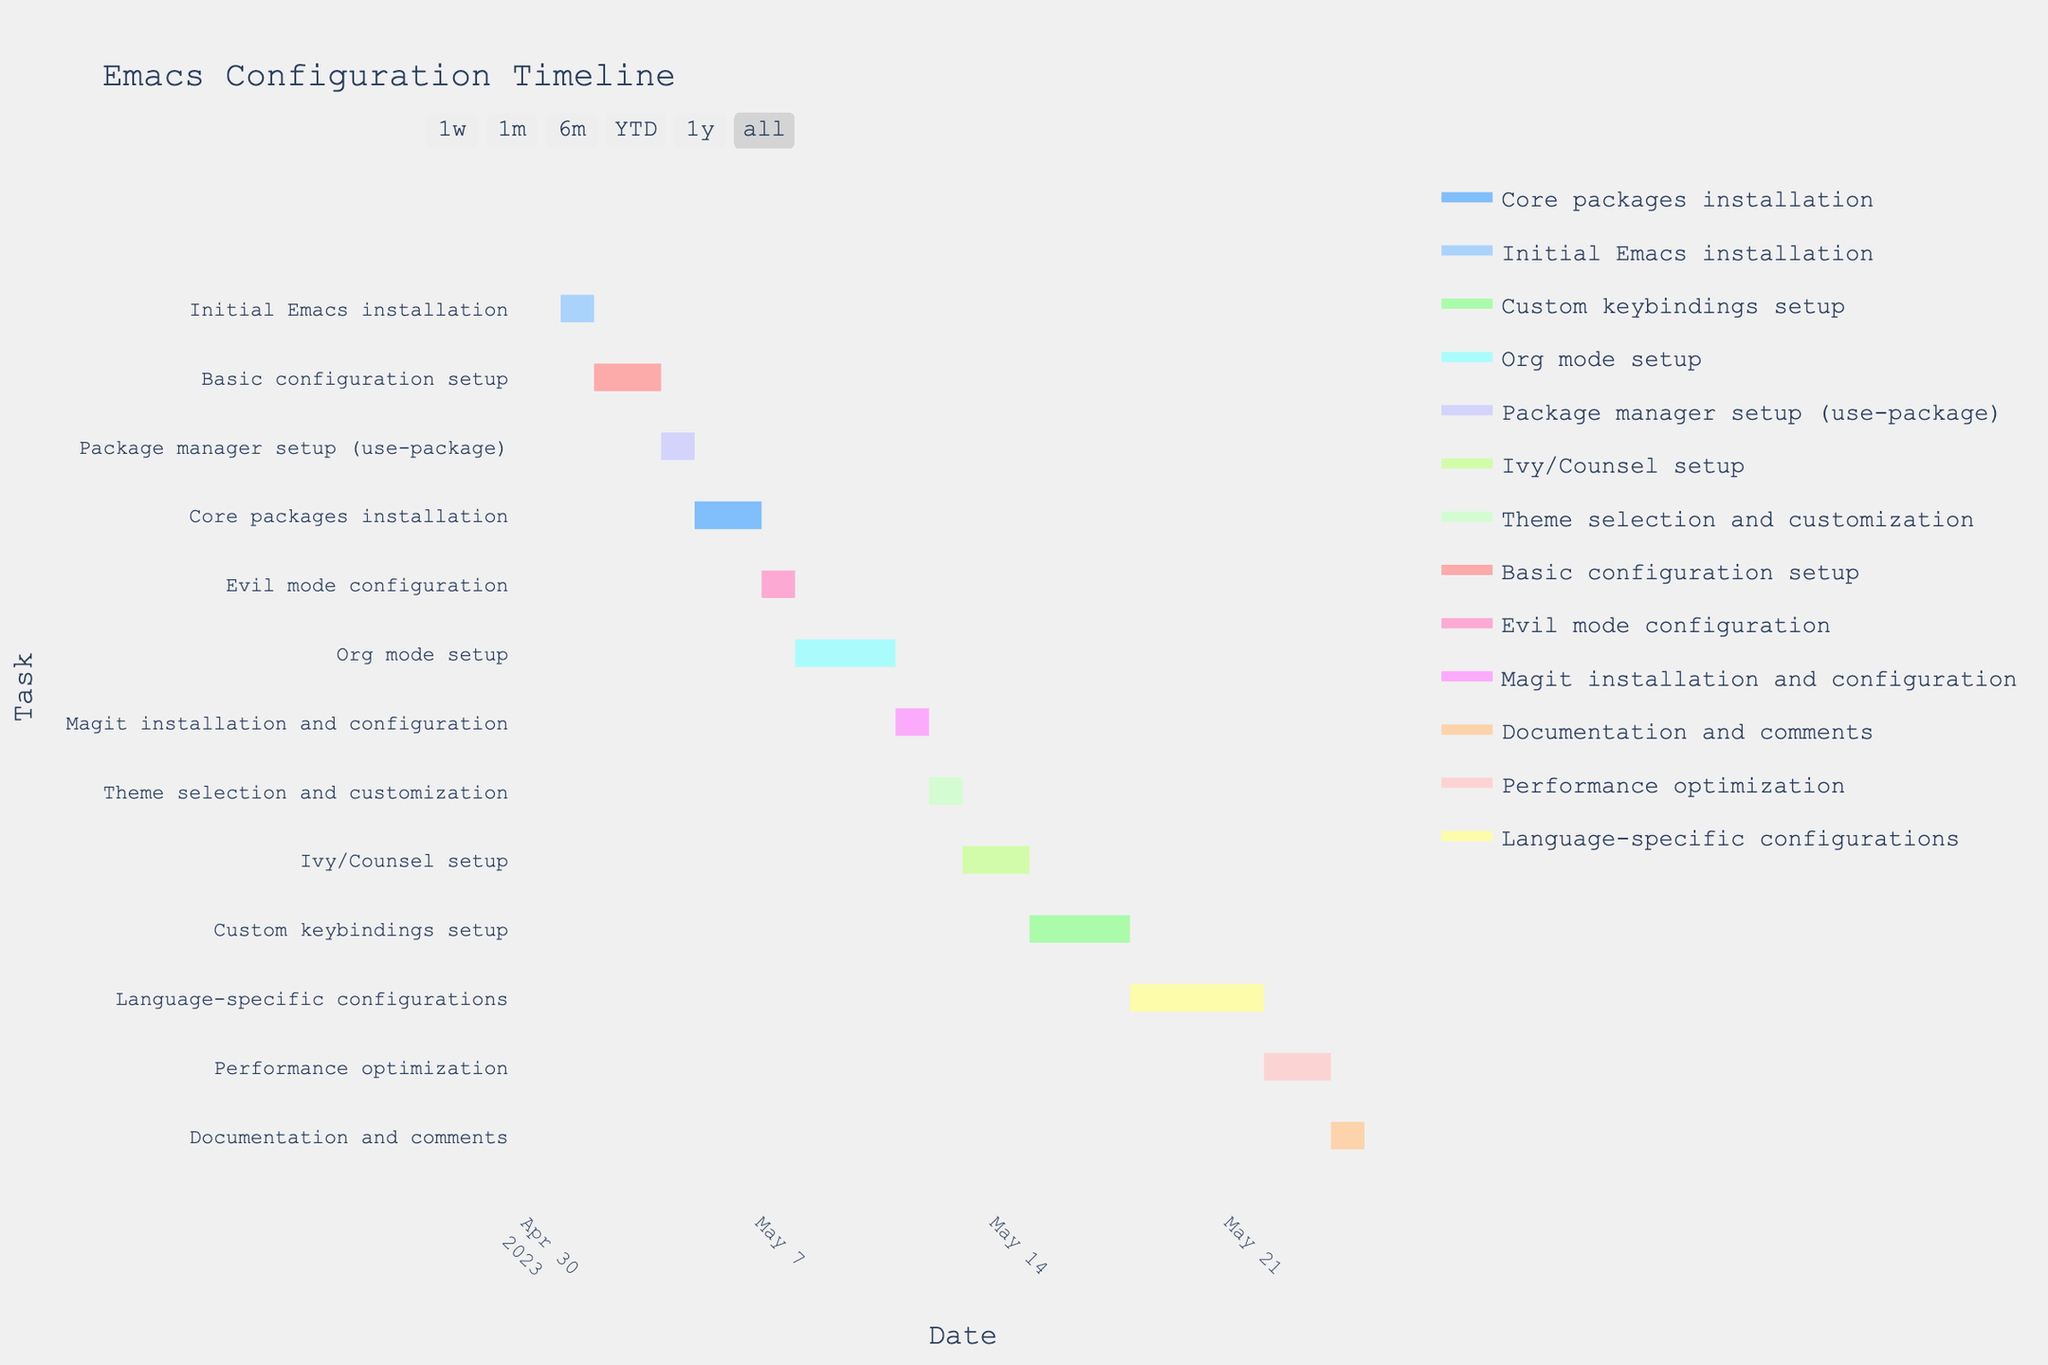what is the title of the Gantt chart? The title of the chart is typically positioned at the top of the figure. It summarises the main topic or the subject of the chart.
Answer: Emacs Configuration Timeline How many days in total are allocated for "Org mode setup"? The duration of "Org mode setup" is given as 3 days.
Answer: 3 What are the start and end dates for "Language-specific configurations"? "Language-specific configurations" starts on 2023-05-18. Adding 4 days of duration, it finishes on 2023-05-22.
Answer: 2023-05-18 to 2023-05-22 Which task takes place immediately after "Core packages installation"? By looking at the sequence of dates, "Evil mode configuration" follows "Core packages installation" on the next day.
Answer: Evil mode configuration Which task has the longest duration? By comparing the 'Duration' column values, "Language-specific configurations" has the longest duration with 4 days.
Answer: Language-specific configurations During which dates does "Basic configuration setup" occur? "Basic configuration setup" starts on 2023-05-02 and lasts for 2 days, which means it occurs from 2023-05-02 to 2023-05-03.
Answer: 2023-05-02 to 2023-05-03 How many tasks are started and finished in May 2023? The Gantt chart shows all tasks within May, and by counting them, there are 13 tasks scheduled within the month.
Answer: 13 Which configuration task starts on the earliest date shown in the chart? "Initial Emacs installation" starts on 2023-05-01, which is the earliest start date on the chart.
Answer: Initial Emacs installation Are there any tasks overlapping in their time allocations? By observing the bars on the chart, "Org mode setup" (2023-05-08 to 2023-05-10) and "Magit installation and configuration" (2023-05-11) have no overlaps, meaning no tasks overlap visually.
Answer: No What is the total duration allocated for setting up "use-package" package manager and "Core packages installation"? Adding the durations: "Package manager setup (use-package)" takes 1 day and "Core packages installation" takes 2 days, totalling 3 days.
Answer: 3 days 